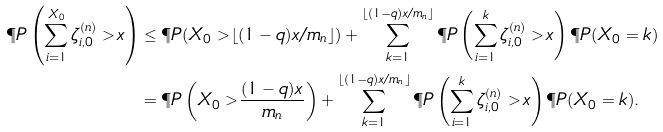Convert formula to latex. <formula><loc_0><loc_0><loc_500><loc_500>\P P \left ( \sum _ { i = 1 } ^ { X _ { 0 } } \zeta _ { i , 0 } ^ { ( n ) } > x \right ) & \leq \P P ( X _ { 0 } > \lfloor ( 1 - q ) x / m _ { n } \rfloor ) + \sum _ { k = 1 } ^ { \lfloor ( 1 - q ) x / m _ { n } \rfloor } \P P \left ( \sum _ { i = 1 } ^ { k } \zeta _ { i , 0 } ^ { ( n ) } > x \right ) \P P ( X _ { 0 } = k ) \\ & = \P P \left ( X _ { 0 } > \frac { ( 1 - q ) x } { m _ { n } } \right ) + \sum _ { k = 1 } ^ { \lfloor ( 1 - q ) x / m _ { n } \rfloor } \P P \left ( \sum _ { i = 1 } ^ { k } \zeta _ { i , 0 } ^ { ( n ) } > x \right ) \P P ( X _ { 0 } = k ) .</formula> 